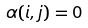<formula> <loc_0><loc_0><loc_500><loc_500>\alpha ( i , j ) = 0</formula> 